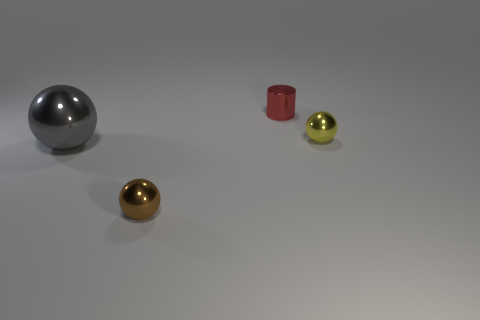Add 1 tiny red cylinders. How many objects exist? 5 Subtract all cylinders. How many objects are left? 3 Add 1 cyan things. How many cyan things exist? 1 Subtract 0 gray blocks. How many objects are left? 4 Subtract all small yellow metal spheres. Subtract all tiny yellow objects. How many objects are left? 2 Add 2 small metallic cylinders. How many small metallic cylinders are left? 3 